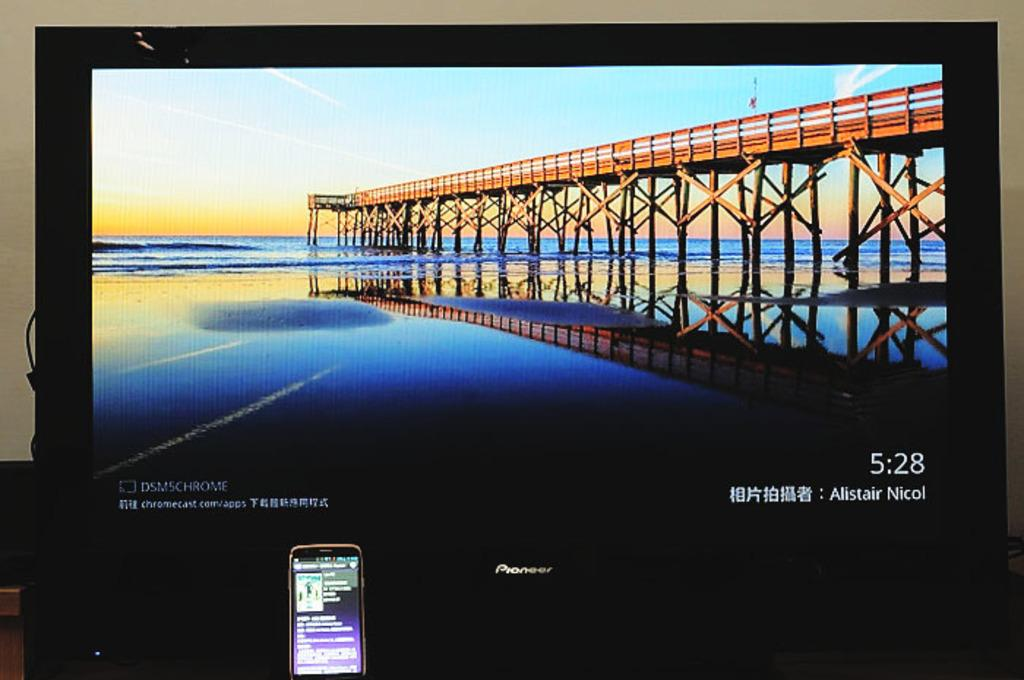<image>
Relay a brief, clear account of the picture shown. A Pioneer brand monitor displays the time of 5:28. 